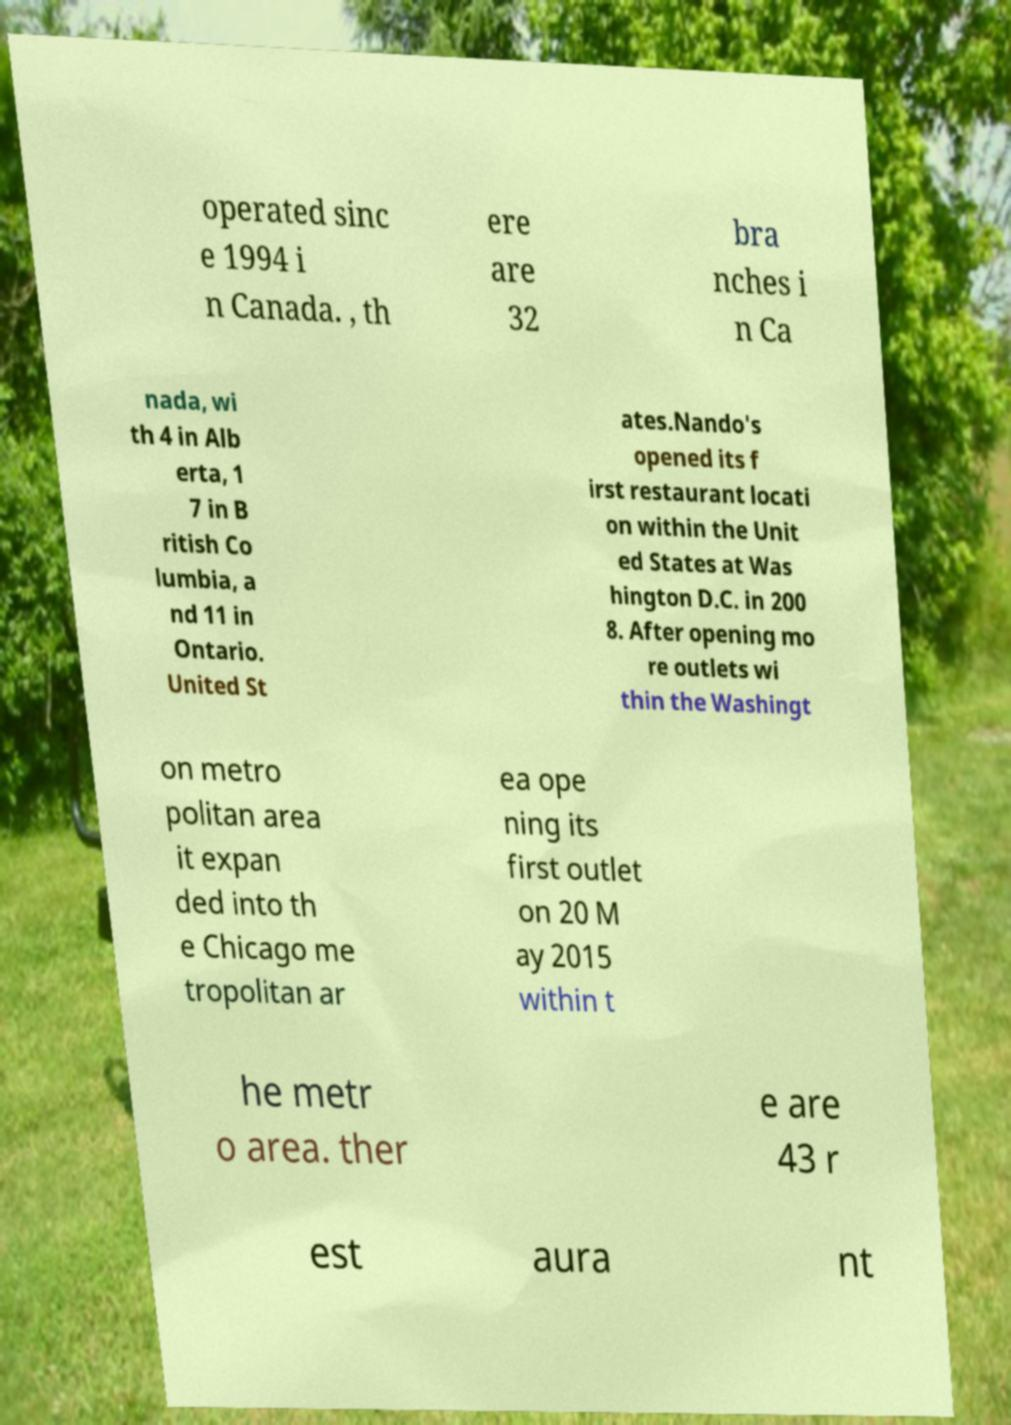Could you assist in decoding the text presented in this image and type it out clearly? operated sinc e 1994 i n Canada. , th ere are 32 bra nches i n Ca nada, wi th 4 in Alb erta, 1 7 in B ritish Co lumbia, a nd 11 in Ontario. United St ates.Nando's opened its f irst restaurant locati on within the Unit ed States at Was hington D.C. in 200 8. After opening mo re outlets wi thin the Washingt on metro politan area it expan ded into th e Chicago me tropolitan ar ea ope ning its first outlet on 20 M ay 2015 within t he metr o area. ther e are 43 r est aura nt 